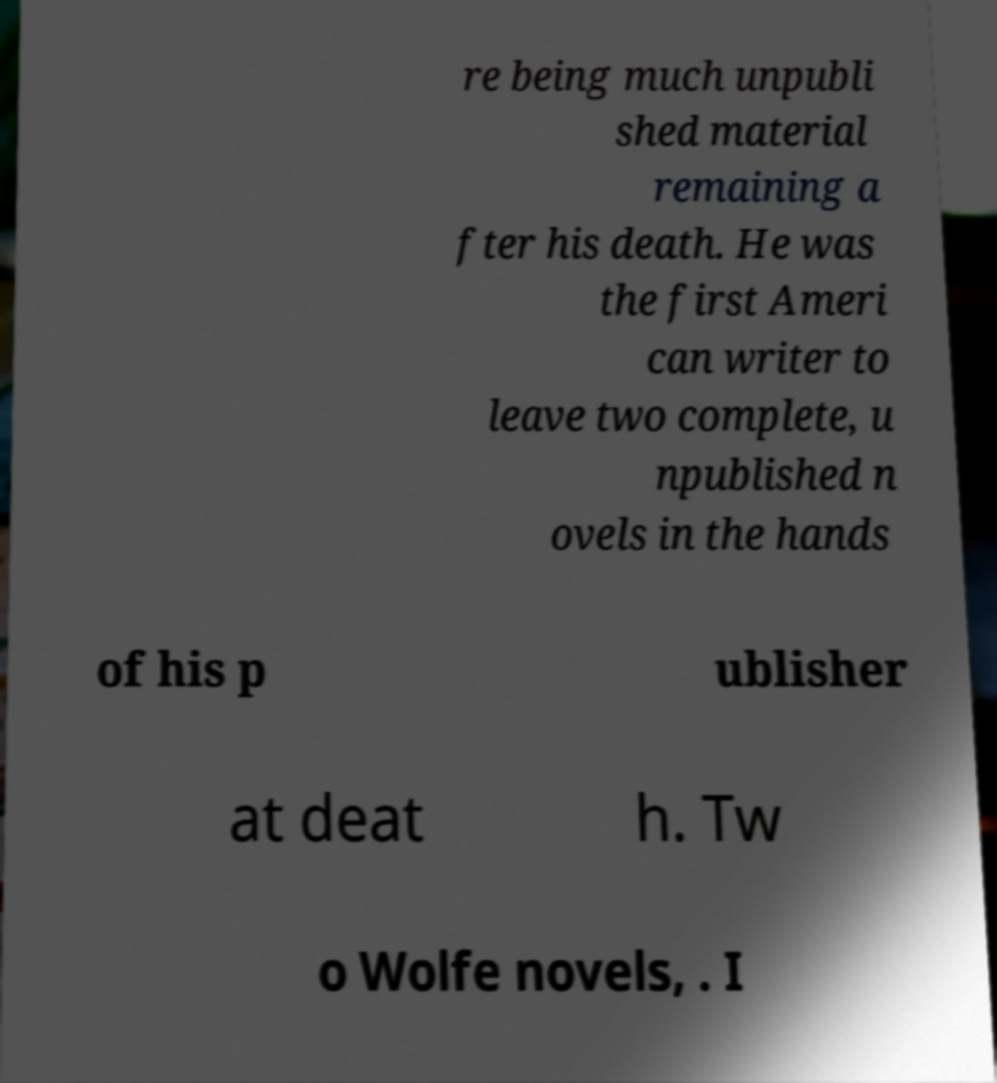For documentation purposes, I need the text within this image transcribed. Could you provide that? re being much unpubli shed material remaining a fter his death. He was the first Ameri can writer to leave two complete, u npublished n ovels in the hands of his p ublisher at deat h. Tw o Wolfe novels, . I 